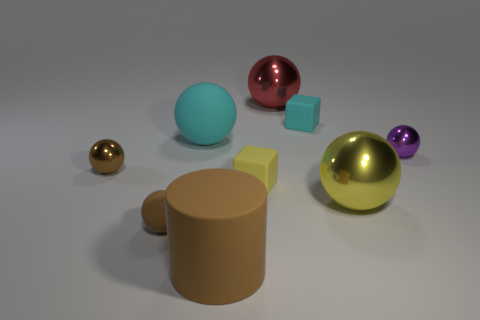How many other objects are there of the same color as the matte cylinder?
Ensure brevity in your answer.  2. There is a large object that is both behind the small yellow matte object and in front of the big red metallic sphere; what is its color?
Provide a succinct answer. Cyan. What number of big green metal cylinders are there?
Give a very brief answer. 0. Is the red thing made of the same material as the purple thing?
Your answer should be compact. Yes. There is a yellow object that is to the right of the small yellow rubber object that is in front of the cyan thing that is left of the big rubber cylinder; what shape is it?
Make the answer very short. Sphere. Is the material of the brown thing behind the tiny yellow object the same as the yellow thing that is left of the yellow shiny sphere?
Ensure brevity in your answer.  No. What material is the purple ball?
Offer a terse response. Metal. How many purple metallic objects have the same shape as the big cyan rubber thing?
Your answer should be very brief. 1. There is a tiny thing that is the same color as the tiny rubber sphere; what is its material?
Offer a very short reply. Metal. Is there any other thing that has the same shape as the big brown object?
Your response must be concise. No. 